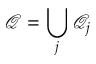<formula> <loc_0><loc_0><loc_500><loc_500>\mathcal { Q } = \bigcup _ { j } \mathcal { Q } _ { j }</formula> 